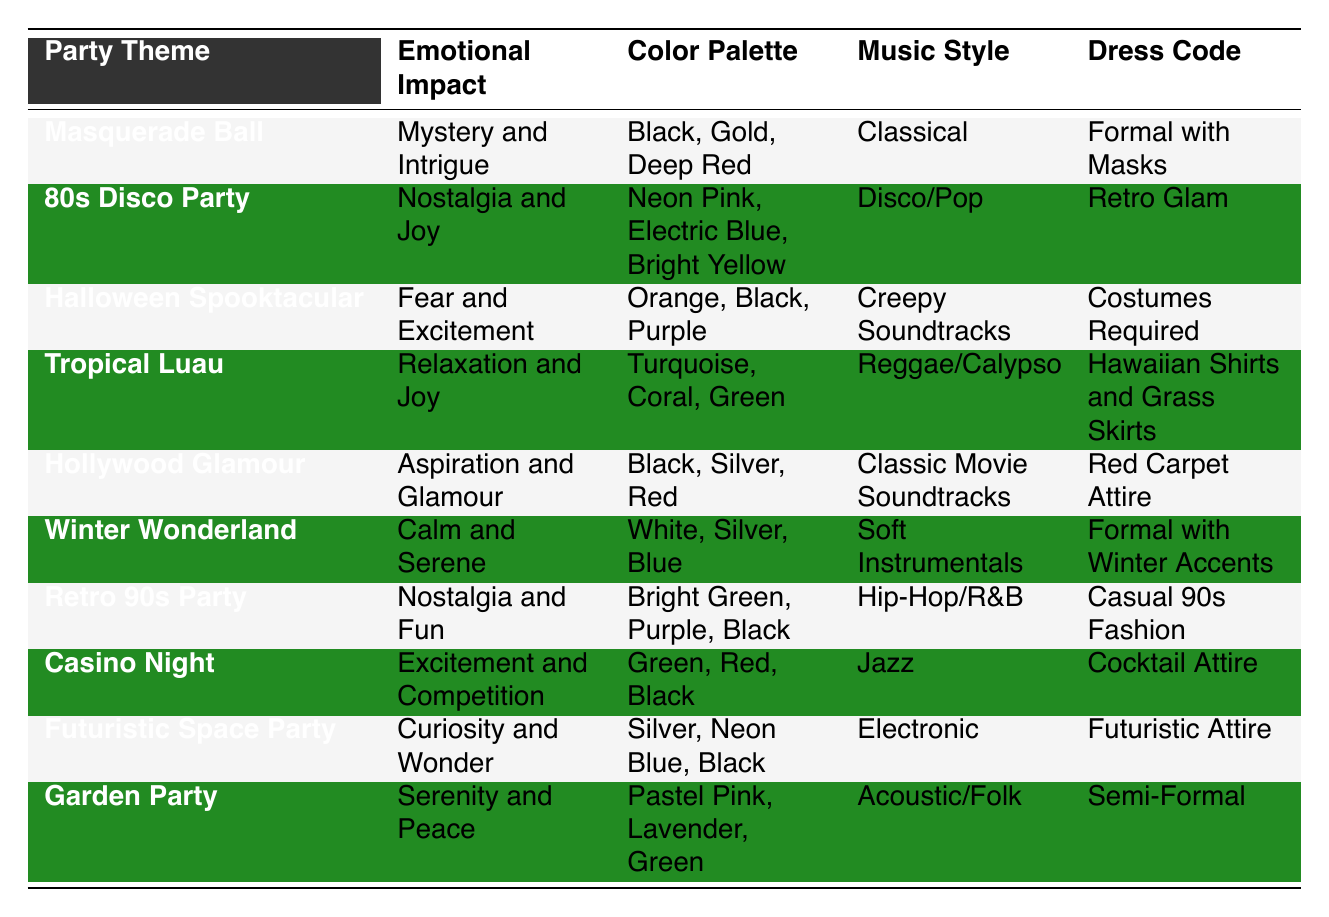What emotional impact is associated with the Halloween Spooktacular party? The "Emotional Impact" column for the Halloween Spooktacular party shows "Fear and Excitement." Therefore, that's the emotional impact associated with this theme.
Answer: Fear and Excitement Which party theme has the color palette of Black, Silver, and Red? By inspecting the "Color Palette" column, the Hollywood Glamour party is the one that has the colors Black, Silver, and Red listed.
Answer: Hollywood Glamour Is the dress code for the Tropical Luau party formal? The "Dress Code" for the Tropical Luau party is "Hawaiian Shirts and Grass Skirts," which is casual rather than formal. Thus, the statement is false.
Answer: No Which party theme is associated with serenity and peace? Looking at the "Emotional Impact" column, the Garden Party has "Serenity and Peace" listed as its emotional impact. Therefore, this is the correct answer.
Answer: Garden Party How many party themes have "Nostalgia" as part of their emotional impact? The themes that mention "Nostalgia" in their emotional impact are the 80s Disco Party and the Retro 90s Party. Thus, there are two such themes.
Answer: 2 Which party theme has a dress code of "Costumes Required"? The Halloween Spooktacular party is noted for needing "Costumes Required" as its dress code, thus confirming the answer.
Answer: Halloween Spooktacular What is the common emotional impact shared by the 80s Disco Party and the Retro 90s Party? Both the 80s Disco Party and the Retro 90s Party share the emotional impact of "Nostalgia" as part of their themes. Therefore, this is the common emotional impact.
Answer: Nostalgia If you combine the color palettes of the Futuristic Space Party and the Hollywood Glamour party, which colors appear? The Futuristic Space Party's palette includes Silver, Neon Blue, and Black, while Hollywood Glamour includes Black, Silver, and Red. The combined colors are Silver, Neon Blue, Black, and Red.
Answer: Silver, Neon Blue, Black, Red How does the emotional impact of the Casino Night party compare to that of the Winter Wonderland party? The emotional impact of the Casino Night party is "Excitement and Competition," while the Winter Wonderland party is "Calm and Serene." The Casino Night's impact is much more energetic compared to the tranquil feeling associated with Winter Wonderland.
Answer: Casino Night is energetic, Winter Wonderland is tranquil 